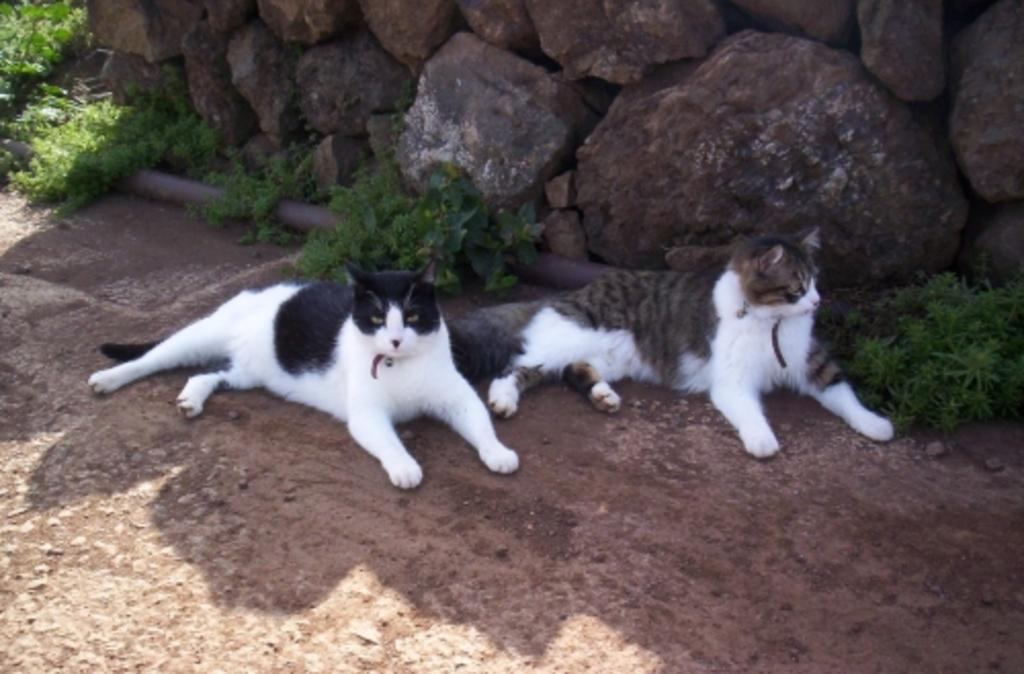What animals are in the center of the image? There are two cats in the center of the image. What can be seen in the background of the image? There are rocks and plants in the background of the image. What is at the bottom of the image? There is a walkway at the bottom of the image. What type of cherries are hanging from the lamp in the image? There is no lamp or cherries present in the image. 